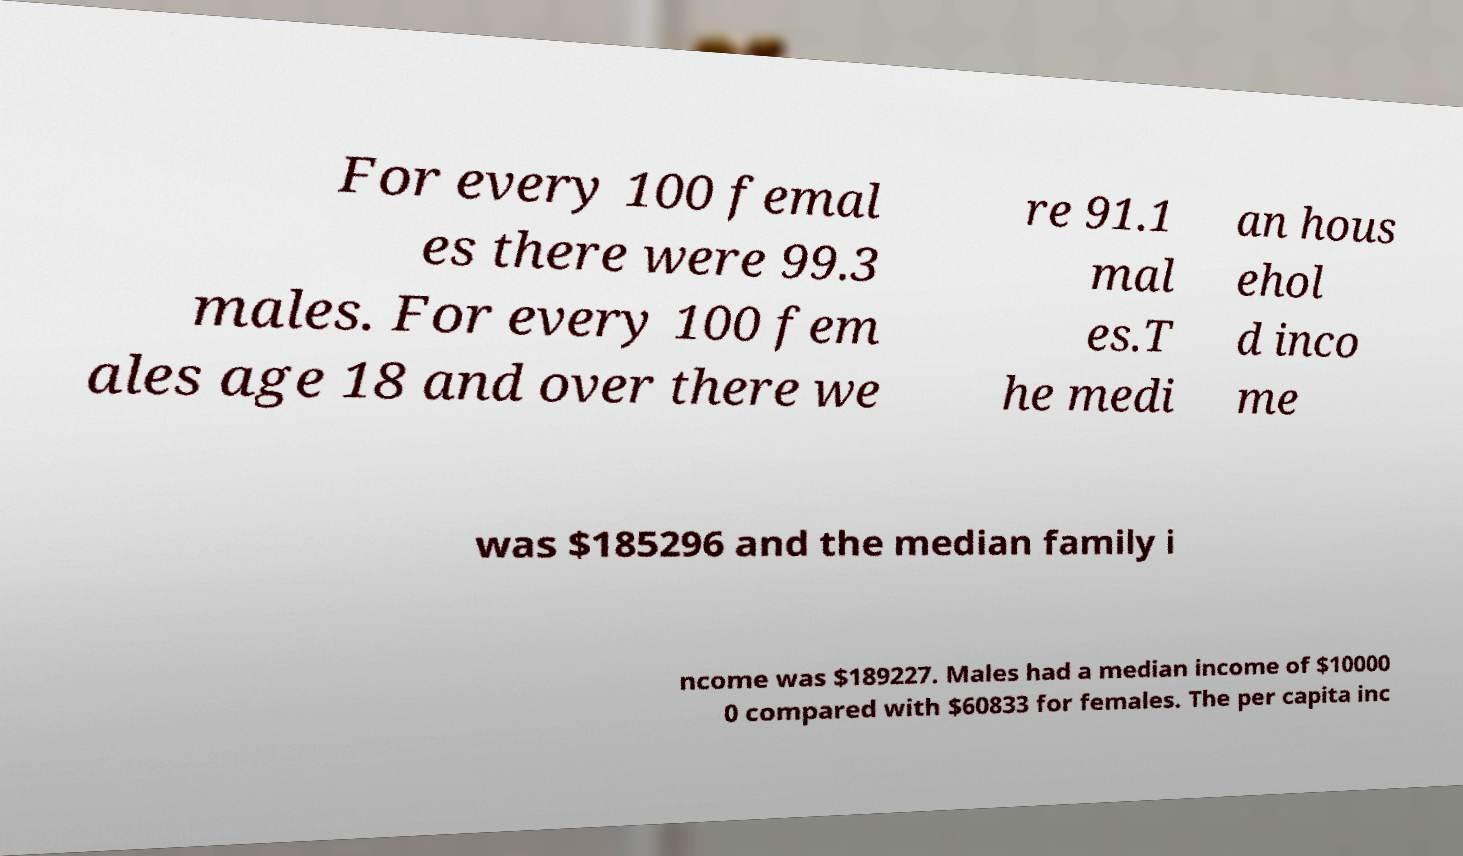What messages or text are displayed in this image? I need them in a readable, typed format. For every 100 femal es there were 99.3 males. For every 100 fem ales age 18 and over there we re 91.1 mal es.T he medi an hous ehol d inco me was $185296 and the median family i ncome was $189227. Males had a median income of $10000 0 compared with $60833 for females. The per capita inc 